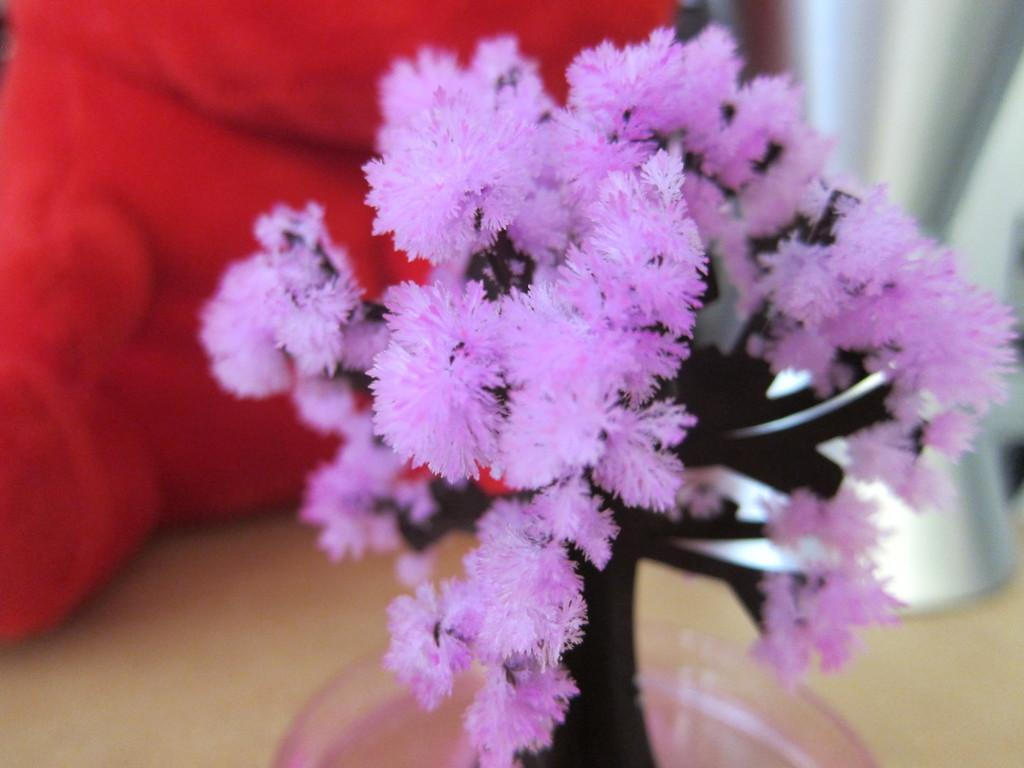What type of tree is in the image? There is an artificial tree in the image. What color are the leaves of the tree? The leaves of the tree are purple. How is the background of the image depicted? The background of the tree is blurred. Can you tell me how many babies are sitting on the tank in the image? There is no tank or babies present in the image; it features an artificial tree with purple leaves and a blurred background. 